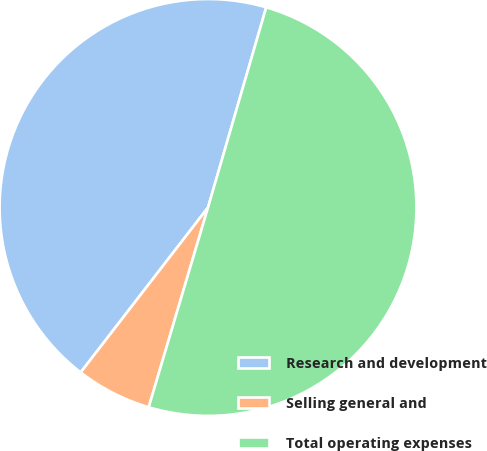Convert chart to OTSL. <chart><loc_0><loc_0><loc_500><loc_500><pie_chart><fcel>Research and development<fcel>Selling general and<fcel>Total operating expenses<nl><fcel>44.04%<fcel>5.87%<fcel>50.09%<nl></chart> 